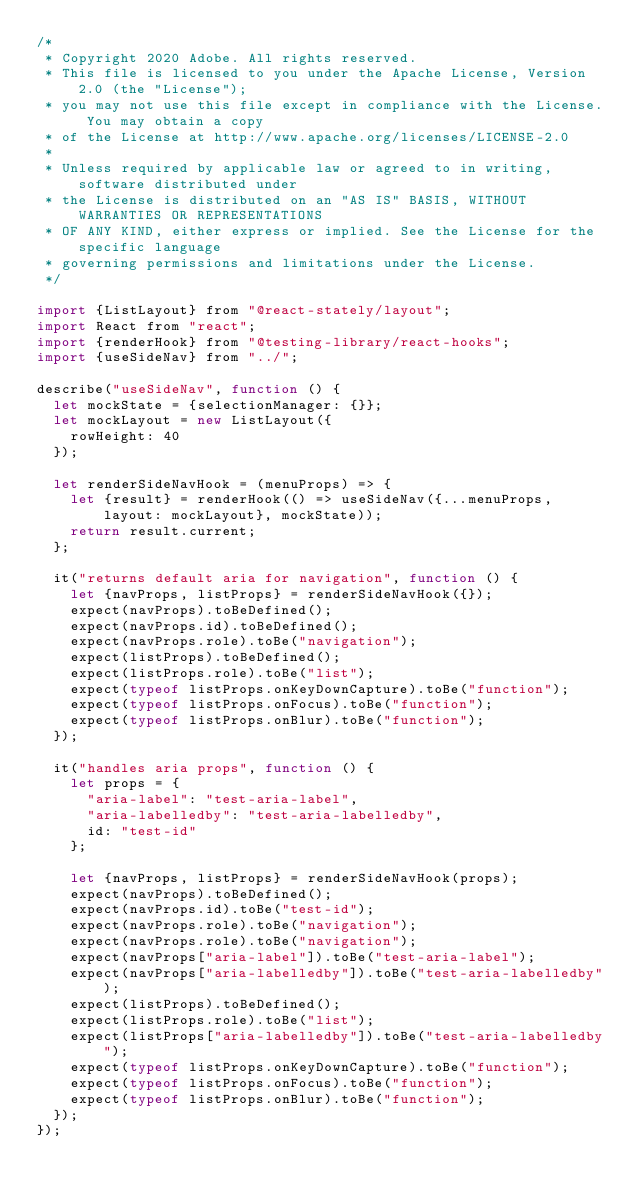<code> <loc_0><loc_0><loc_500><loc_500><_JavaScript_>/*
 * Copyright 2020 Adobe. All rights reserved.
 * This file is licensed to you under the Apache License, Version 2.0 (the "License");
 * you may not use this file except in compliance with the License. You may obtain a copy
 * of the License at http://www.apache.org/licenses/LICENSE-2.0
 *
 * Unless required by applicable law or agreed to in writing, software distributed under
 * the License is distributed on an "AS IS" BASIS, WITHOUT WARRANTIES OR REPRESENTATIONS
 * OF ANY KIND, either express or implied. See the License for the specific language
 * governing permissions and limitations under the License.
 */

import {ListLayout} from "@react-stately/layout";
import React from "react";
import {renderHook} from "@testing-library/react-hooks";
import {useSideNav} from "../";

describe("useSideNav", function () {
  let mockState = {selectionManager: {}};
  let mockLayout = new ListLayout({
    rowHeight: 40
  });

  let renderSideNavHook = (menuProps) => {
    let {result} = renderHook(() => useSideNav({...menuProps, layout: mockLayout}, mockState));
    return result.current;
  };

  it("returns default aria for navigation", function () {
    let {navProps, listProps} = renderSideNavHook({});
    expect(navProps).toBeDefined();
    expect(navProps.id).toBeDefined();
    expect(navProps.role).toBe("navigation");
    expect(listProps).toBeDefined();
    expect(listProps.role).toBe("list");
    expect(typeof listProps.onKeyDownCapture).toBe("function");
    expect(typeof listProps.onFocus).toBe("function");
    expect(typeof listProps.onBlur).toBe("function");
  });

  it("handles aria props", function () {
    let props = {
      "aria-label": "test-aria-label",
      "aria-labelledby": "test-aria-labelledby",
      id: "test-id"
    };

    let {navProps, listProps} = renderSideNavHook(props);
    expect(navProps).toBeDefined();
    expect(navProps.id).toBe("test-id");
    expect(navProps.role).toBe("navigation");
    expect(navProps.role).toBe("navigation");
    expect(navProps["aria-label"]).toBe("test-aria-label");
    expect(navProps["aria-labelledby"]).toBe("test-aria-labelledby");
    expect(listProps).toBeDefined();
    expect(listProps.role).toBe("list");
    expect(listProps["aria-labelledby"]).toBe("test-aria-labelledby");
    expect(typeof listProps.onKeyDownCapture).toBe("function");
    expect(typeof listProps.onFocus).toBe("function");
    expect(typeof listProps.onBlur).toBe("function");
  });
});
</code> 